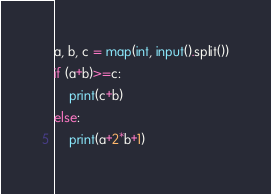Convert code to text. <code><loc_0><loc_0><loc_500><loc_500><_Python_>a, b, c = map(int, input().split())
if (a+b)>=c:
	print(c+b)
else:
	print(a+2*b+1)</code> 